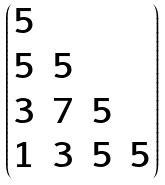Convert formula to latex. <formula><loc_0><loc_0><loc_500><loc_500>\begin{pmatrix} 5 & & & \\ 5 & 5 & & \\ 3 & 7 & 5 & \\ 1 & 3 & 5 & 5 \end{pmatrix}</formula> 